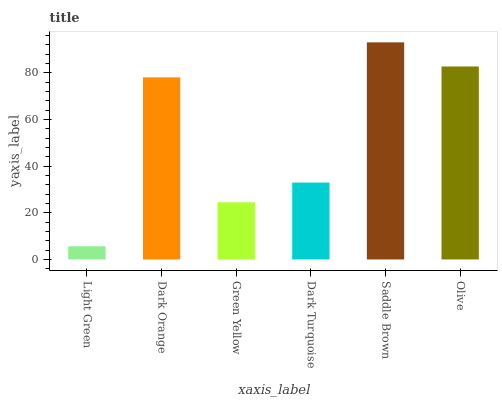Is Dark Orange the minimum?
Answer yes or no. No. Is Dark Orange the maximum?
Answer yes or no. No. Is Dark Orange greater than Light Green?
Answer yes or no. Yes. Is Light Green less than Dark Orange?
Answer yes or no. Yes. Is Light Green greater than Dark Orange?
Answer yes or no. No. Is Dark Orange less than Light Green?
Answer yes or no. No. Is Dark Orange the high median?
Answer yes or no. Yes. Is Dark Turquoise the low median?
Answer yes or no. Yes. Is Saddle Brown the high median?
Answer yes or no. No. Is Dark Orange the low median?
Answer yes or no. No. 